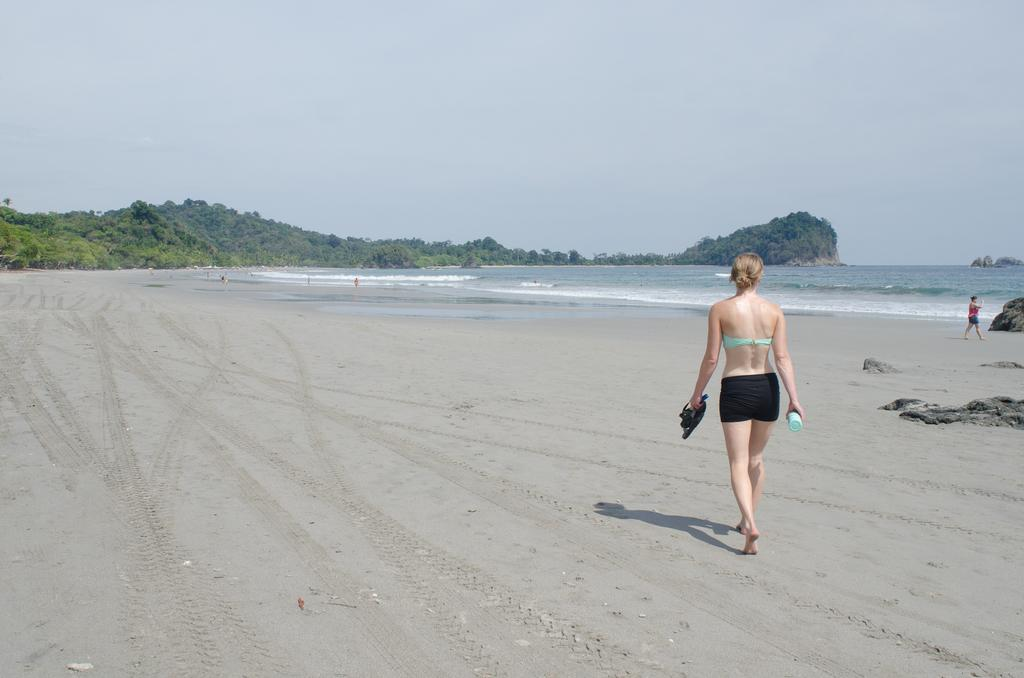What is the woman in the image doing? The woman is walking in the image. Where is the woman walking? The woman is on a beach. What can be seen in the background of the image? There are trees and water visible in the background of the image. What is visible at the top of the image? The sky is visible at the top of the image. How many tickets can be seen in the woman's hand in the image? There are no tickets visible in the woman's hand in the image. What type of fire can be seen on the beach in the image? There is no fire present in the image; it is a woman walking on a beach with trees, water, and sky visible. 